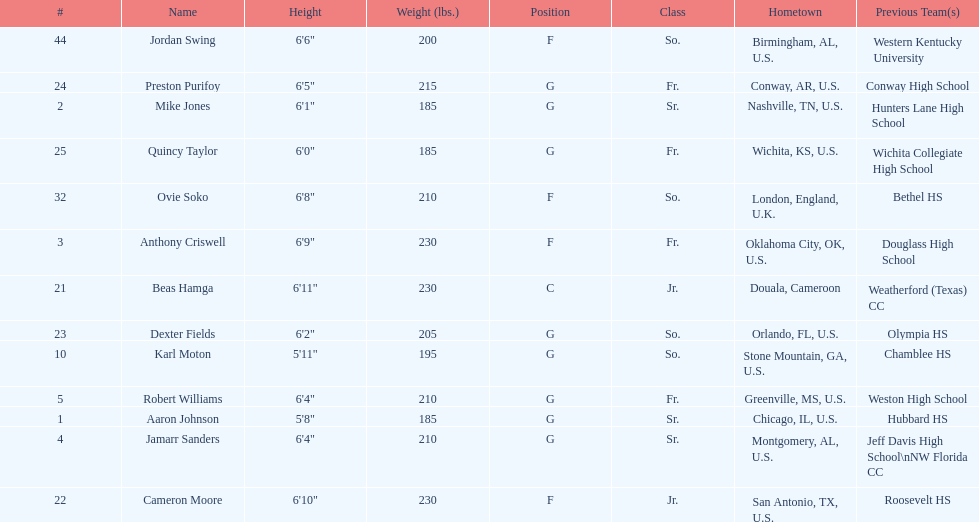Who is the tallest player on the team? Beas Hamga. 